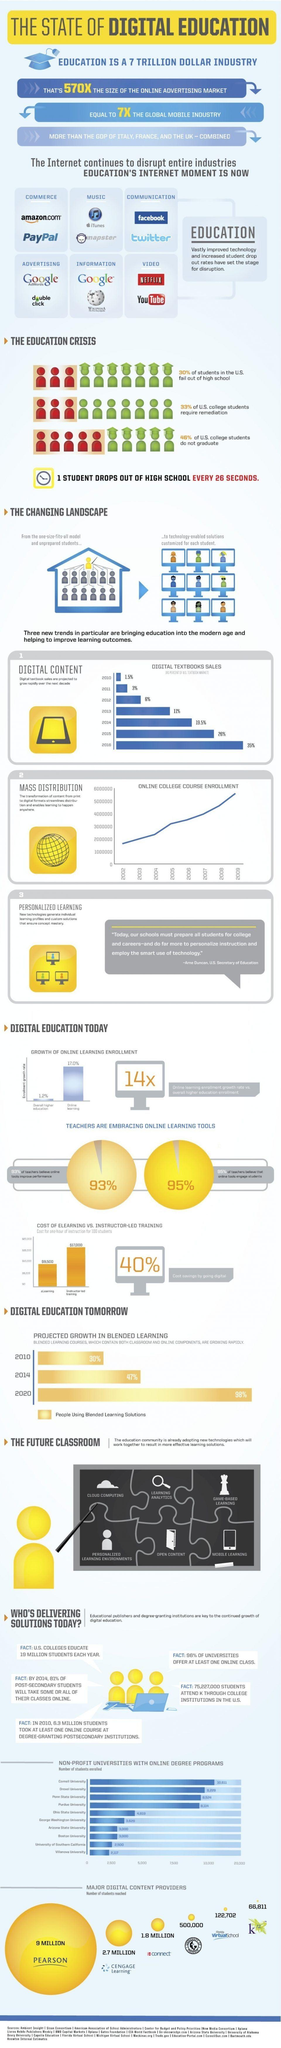Outline some significant characteristics in this image. Google and Wikipedia are the two most widely used internet tools for obtaining information. Pearson is the company with the highest market share in providing digital content. Amazon and PayPal are the two most popular internet tools used for making online payments. The Florida Virtual School is the second company with the lowest market share in providing digital content. According to the information provided, approximately 2.7 million students use the CEngage learning platform for digital content. 